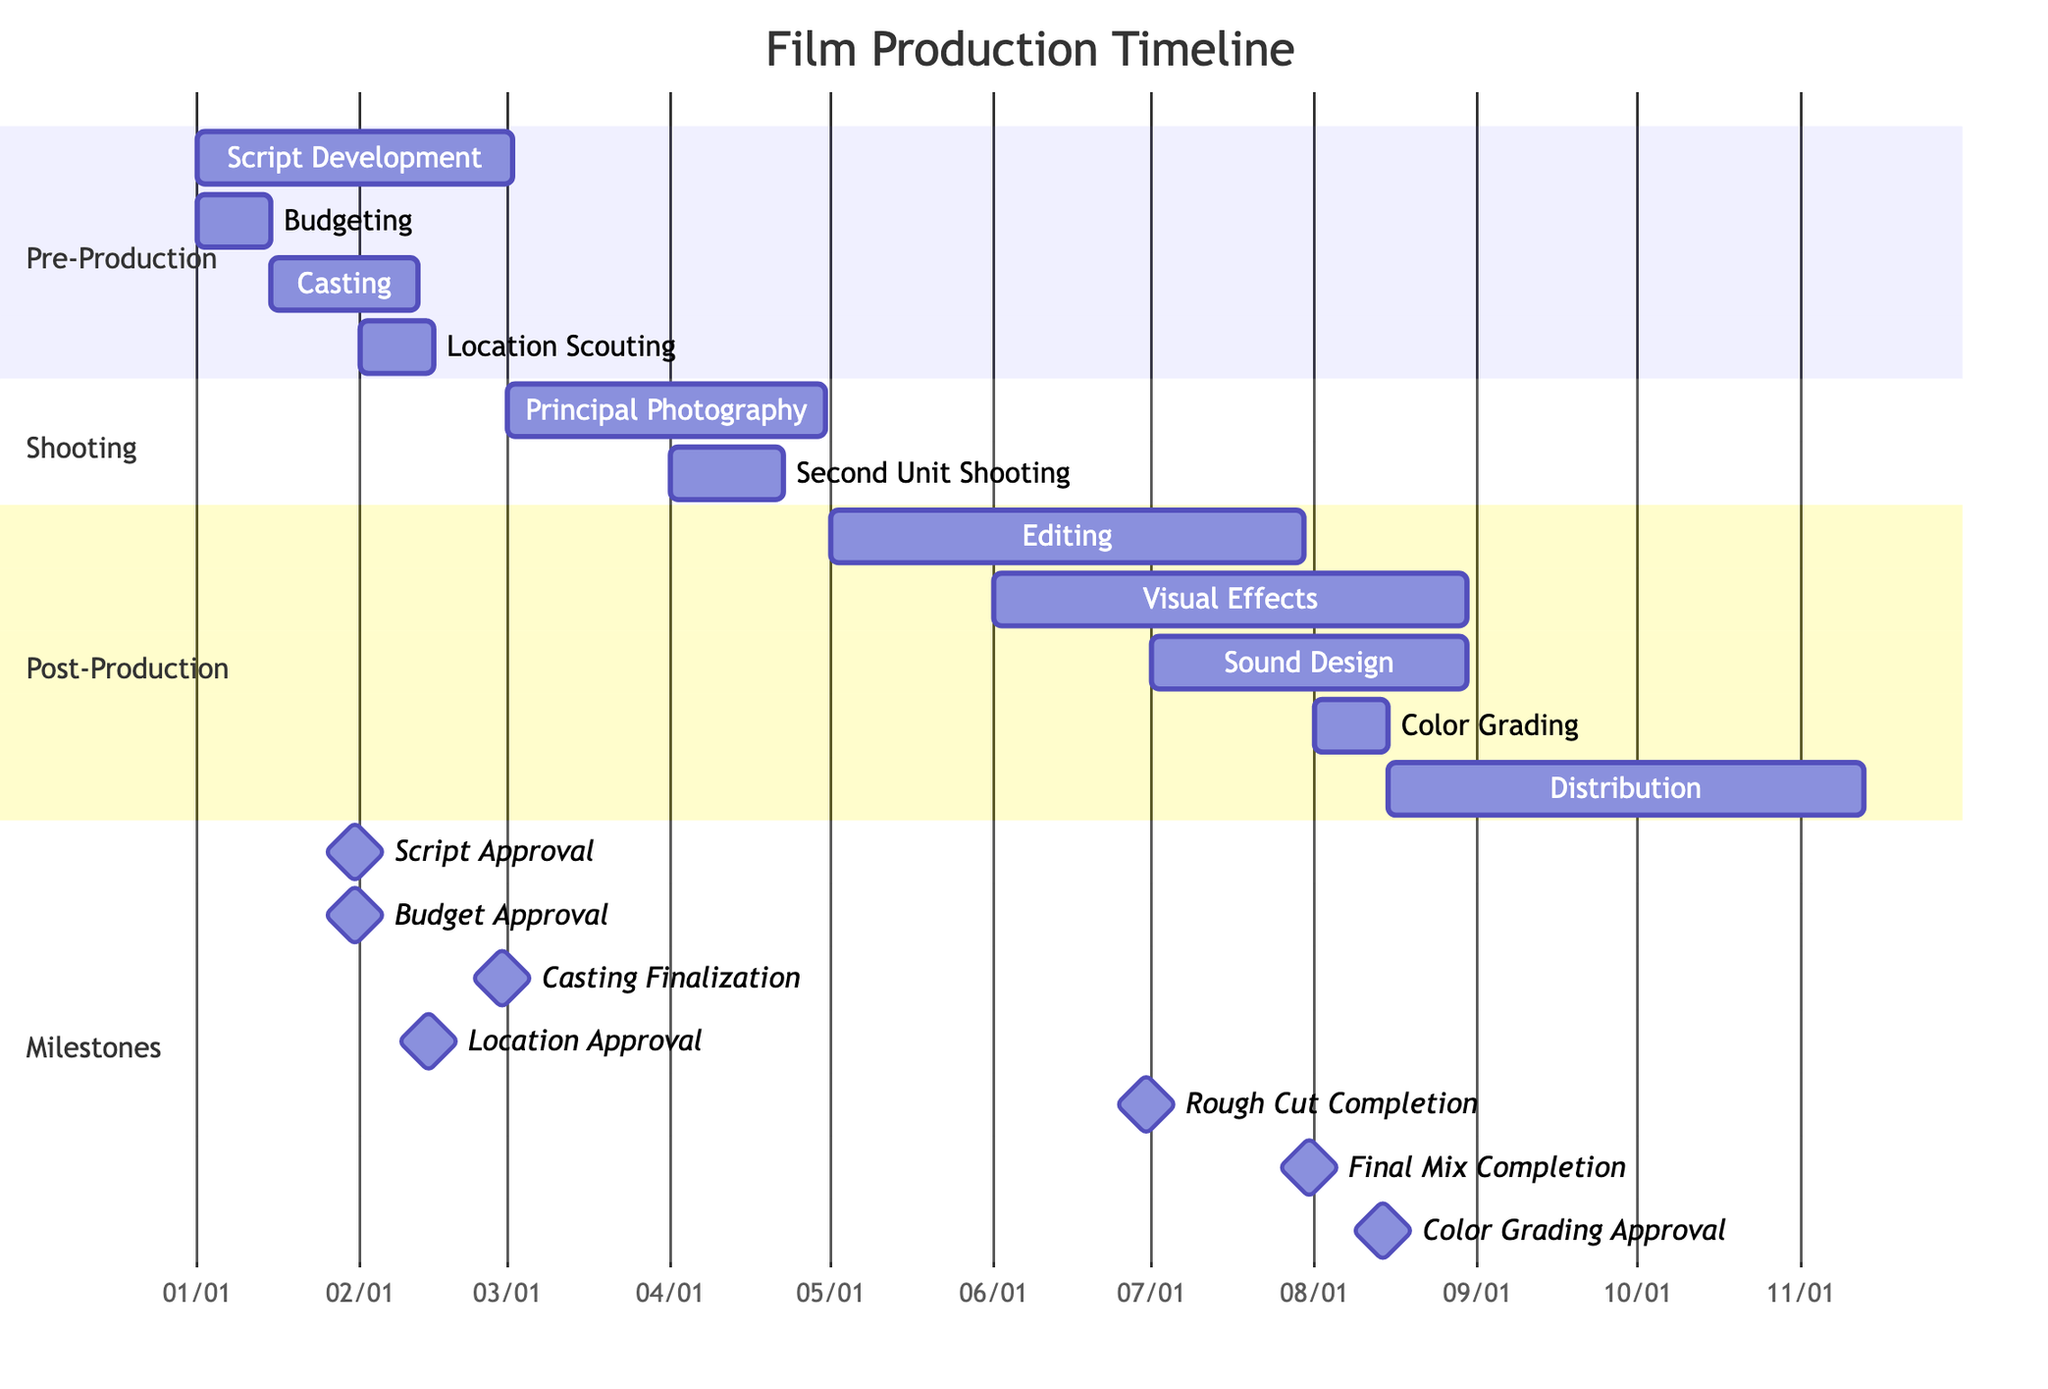What is the duration of Script Development? The duration for Script Development is indicated as 60 days, starting from January 1, 2023.
Answer: 60 days When does Principal Photography start? Principal Photography starts on March 1, 2023, as depicted in the shooting section of the diagram.
Answer: March 1, 2023 How many days are allocated for Sound Design? Sound Design is allocated 60 days, as shown in the post-production section of the diagram.
Answer: 60 days What milestone is reached on January 31, 2023? The milestones reached on January 31, 2023, include both Script Approval and Budget Approval, as they are noted under the milestones section at the same date.
Answer: Script Approval and Budget Approval Which task begins immediately after Casting? After Casting, which ends on February 28, 2023, the next task is Location Scouting, starting on February 1, 2023.
Answer: Location Scouting What is the end date of Editing? Editing starts on May 1, 2023, and lasts for 90 days, thus it ends on July 30, 2023, calculated by adding the duration to the start date.
Answer: July 30, 2023 What section has the most tasks? The post-production section includes four tasks: Editing, Visual Effects, Sound Design, and Color Grading, making it the section with the most tasks.
Answer: Post-Production When will the Rough Cut Completion milestone be achieved? The Rough Cut Completion milestone is scheduled for June 30, 2023, as noted in the milestones section of the diagram.
Answer: June 30, 2023 